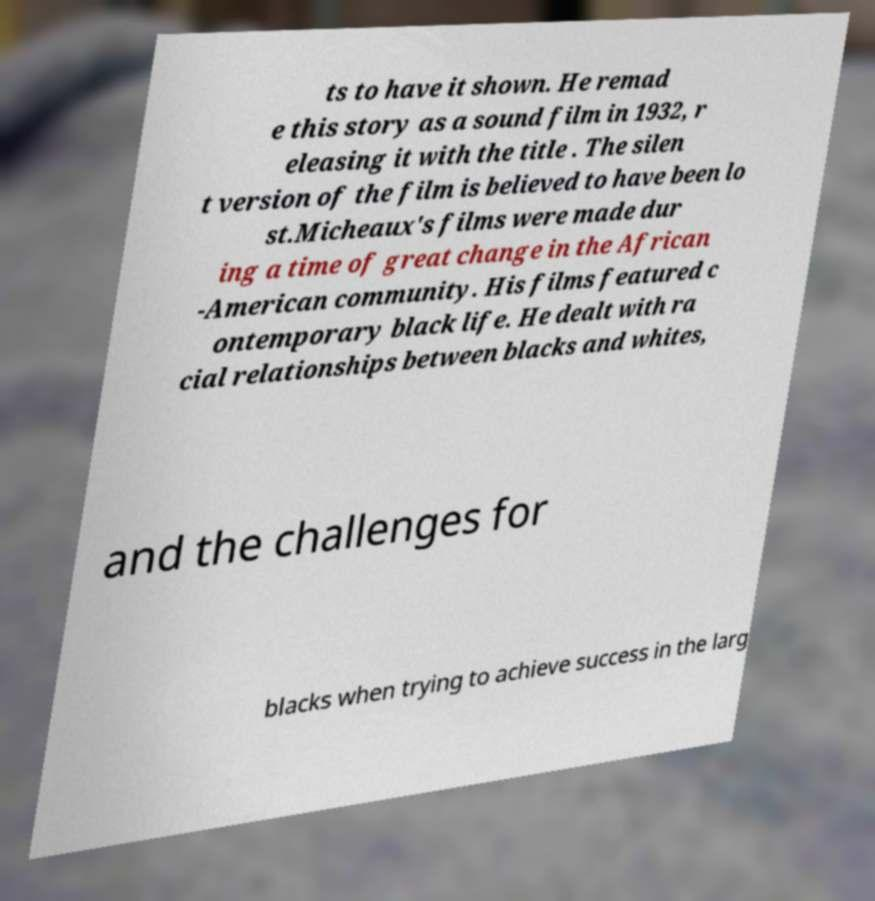Can you read and provide the text displayed in the image?This photo seems to have some interesting text. Can you extract and type it out for me? ts to have it shown. He remad e this story as a sound film in 1932, r eleasing it with the title . The silen t version of the film is believed to have been lo st.Micheaux's films were made dur ing a time of great change in the African -American community. His films featured c ontemporary black life. He dealt with ra cial relationships between blacks and whites, and the challenges for blacks when trying to achieve success in the larg 